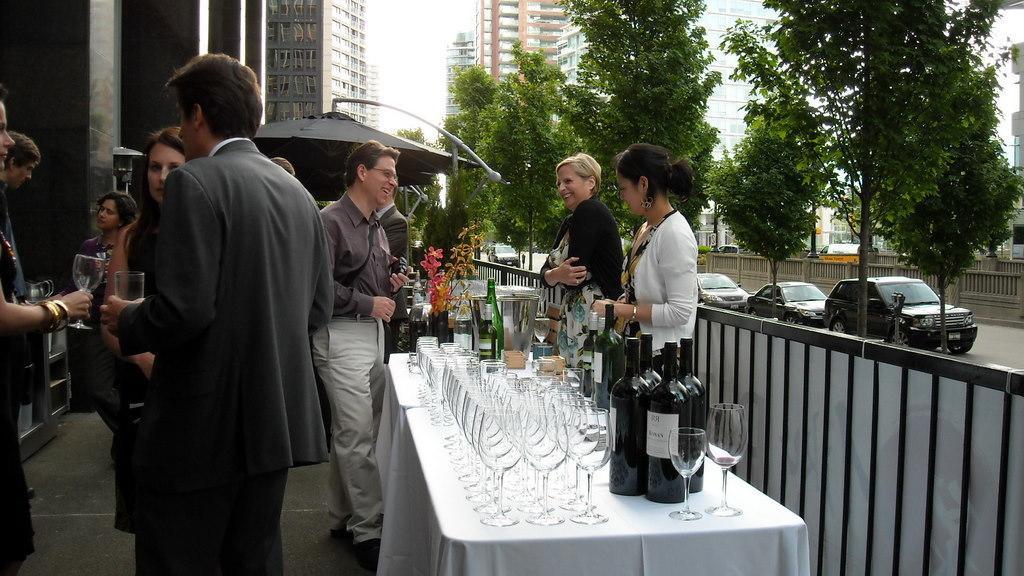Could you give a brief overview of what you see in this image? There are many people standing. On the right side people are holding glasses. And there is a table in the front. On the table there are glasses, bottles and a flower vase. On the right side there railings, vehicles parked on the road and also there are trees. In the background there are buildings. 